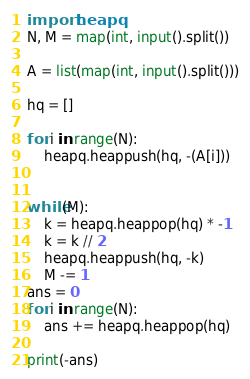<code> <loc_0><loc_0><loc_500><loc_500><_Python_>import heapq
N, M = map(int, input().split())

A = list(map(int, input().split()))

hq = []

for i in range(N):
    heapq.heappush(hq, -(A[i]))


while(M):
    k = heapq.heappop(hq) * -1
    k = k // 2
    heapq.heappush(hq, -k)
    M -= 1
ans = 0
for i in range(N):
    ans += heapq.heappop(hq)

print(-ans)
</code> 